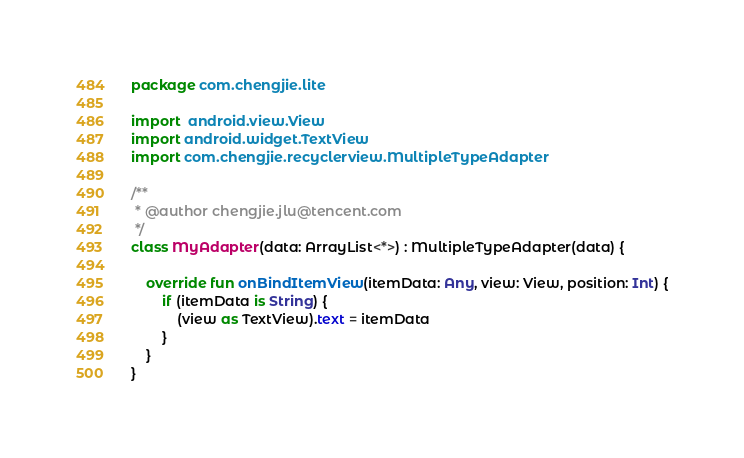Convert code to text. <code><loc_0><loc_0><loc_500><loc_500><_Kotlin_>package com.chengjie.lite

import  android.view.View
import android.widget.TextView
import com.chengjie.recyclerview.MultipleTypeAdapter

/**
 * @author chengjie.jlu@tencent.com
 */
class MyAdapter(data: ArrayList<*>) : MultipleTypeAdapter(data) {

    override fun onBindItemView(itemData: Any, view: View, position: Int) {
        if (itemData is String) {
            (view as TextView).text = itemData
        }
    }
}</code> 